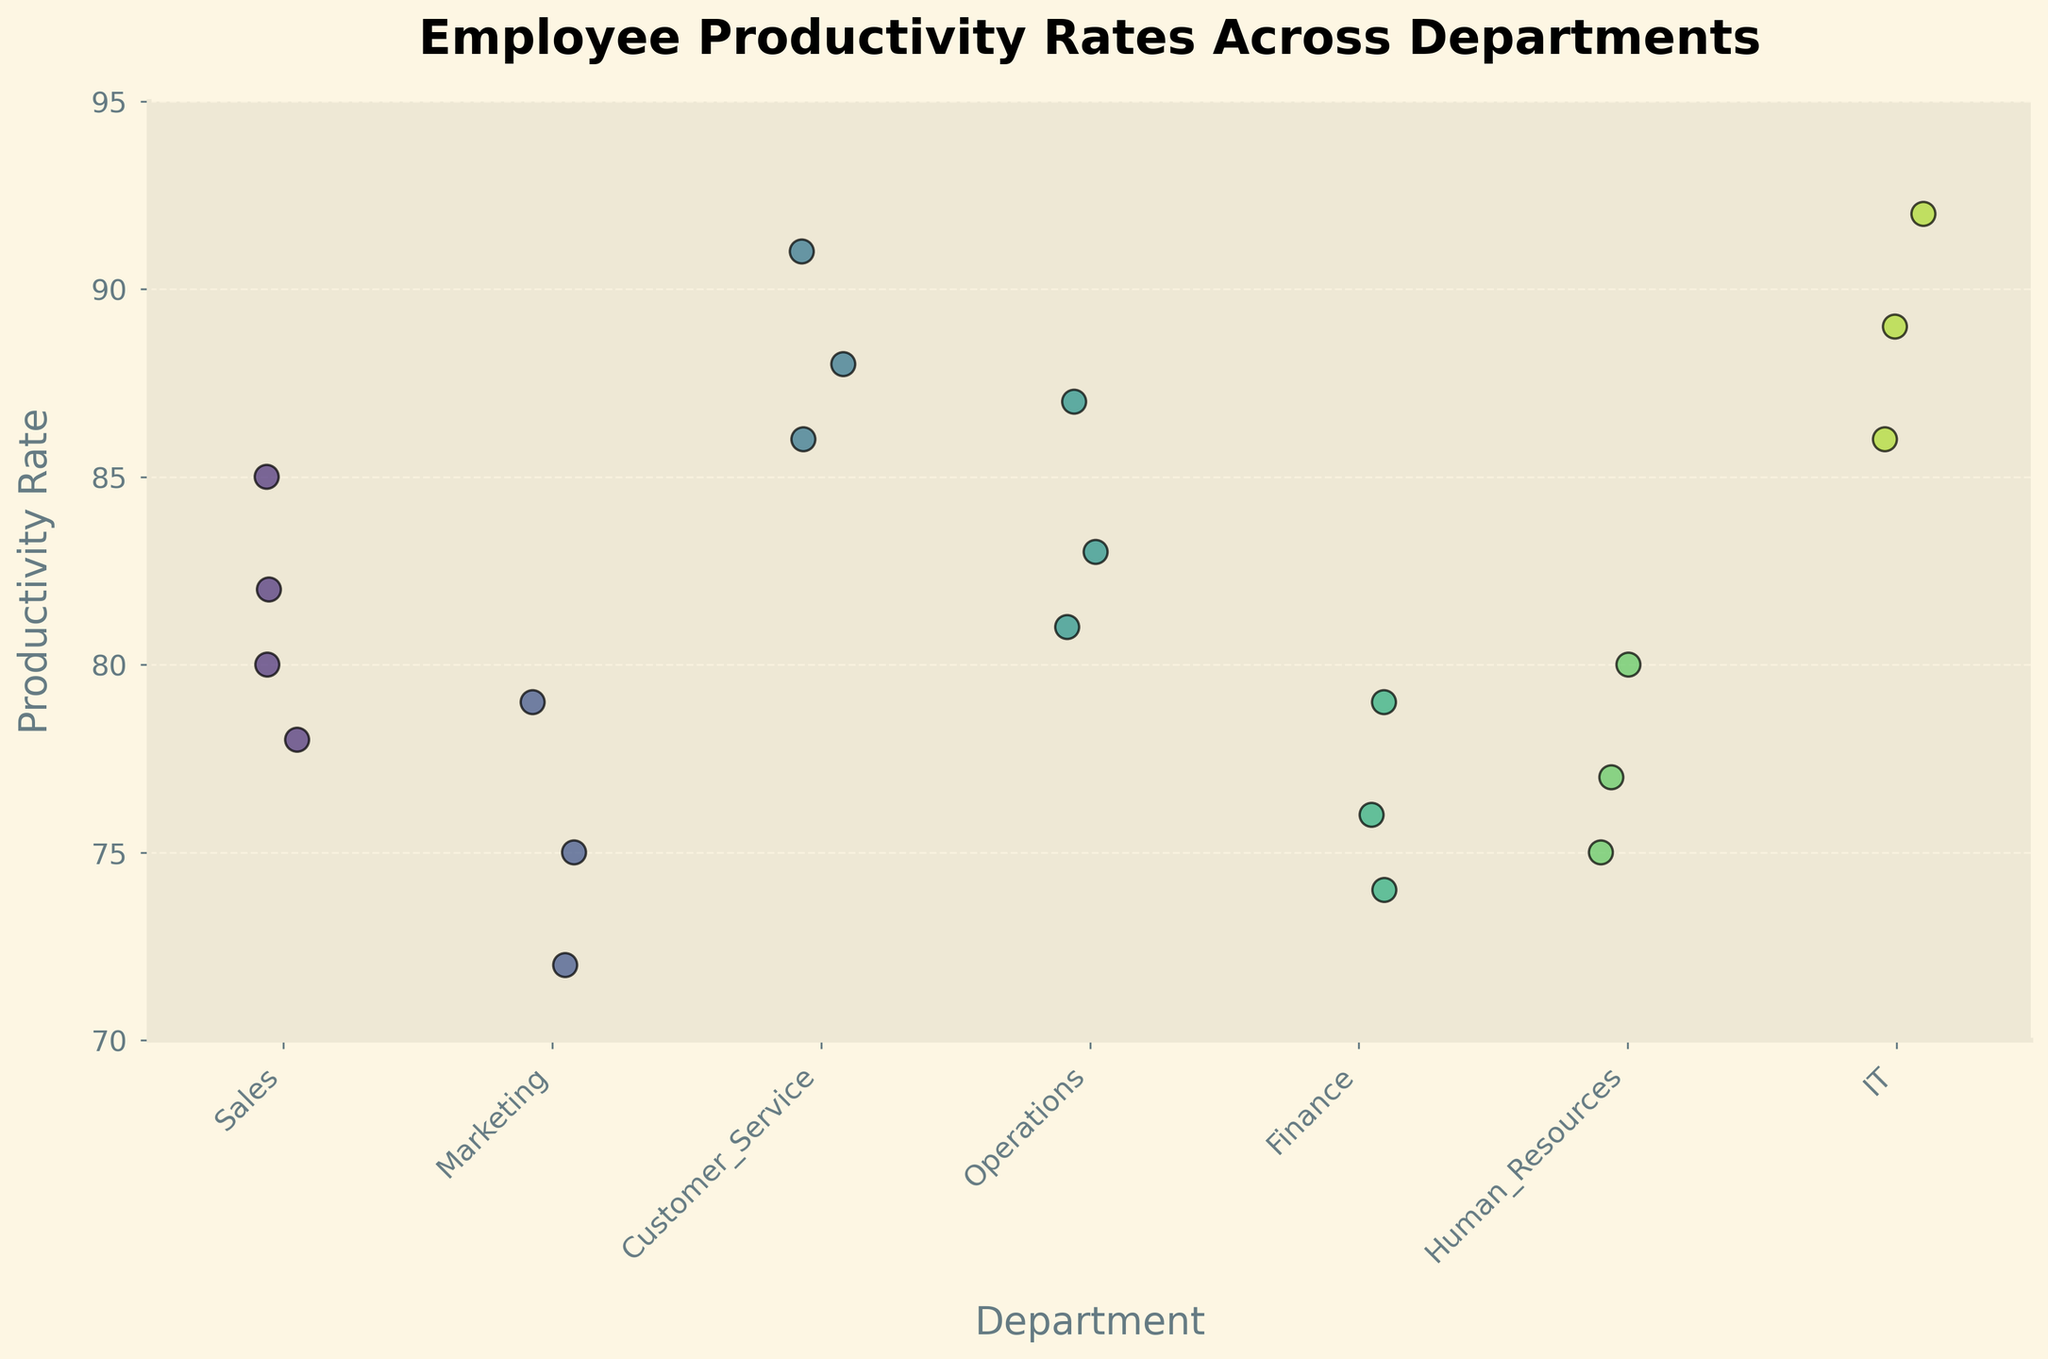What's the title of the plot? The title is the first thing at the top of the plot, usually in a larger, bold font. It provides a brief summary of what the plot represents. The title of this plot is "Employee Productivity Rates Across Departments".
Answer: Employee Productivity Rates Across Departments Which department has the highest productivity rate? By looking at the vertical positions of the dots for each department, the highest dot represents the highest productivity rate. The IT department has the highest rate at 92.
Answer: IT How many data points are there in the Customer Service department? The number of data points can be counted directly from the dots within the Customer Service category on the x-axis. There are 3 data points in this department.
Answer: 3 What's the range of productivity rates in the Sales department? The range is the difference between the highest and lowest values. For Sales, the highest rate is 85 and the lowest is 78. Therefore, the range is 85 - 78 = 7.
Answer: 7 Which two departments have similar median productivity rates? To determine the median, identify the middle value when the data points are ordered. Both Sales and Operations have midpoints around 82-83, indicating they have similar medians.
Answer: Sales and Operations Which department has the lowest productivity rate and what is it? To find the lowest rate, look for the lowest dot among all departments. Finance has the lowest productivity rate at 74.
Answer: Finance, 74 How does the average productivity rate of the IT department compare to the Finance department? Calculate the average for both departments. IT rates are 89, 92, and 86. The average is (89+92+86)/3 = 89. Finance rates are 76, 79, and 74. The average is (76+79+74)/3 = 76.33. IT's average is higher.
Answer: IT has a higher average What is the overall trend in productivity rates among departments? Observe the central tendency and spread of the dots for each department. IT and Customer Service generally have higher productivity rates compared to Sales, Marketing, Finance, and Human Resources.
Answer: IT and Customer Service are higher Which department exhibits the most consistent productivity rates? Consistency can be judged by the spread of the data points. Customer Service has data points close together (88, 91, 86), indicating high consistency.
Answer: Customer Service What's the difference in the highest productivity rates between the IT and Marketing departments? The highest rate in IT is 92 and in Marketing is 79. The difference is 92 - 79 = 13.
Answer: 13 